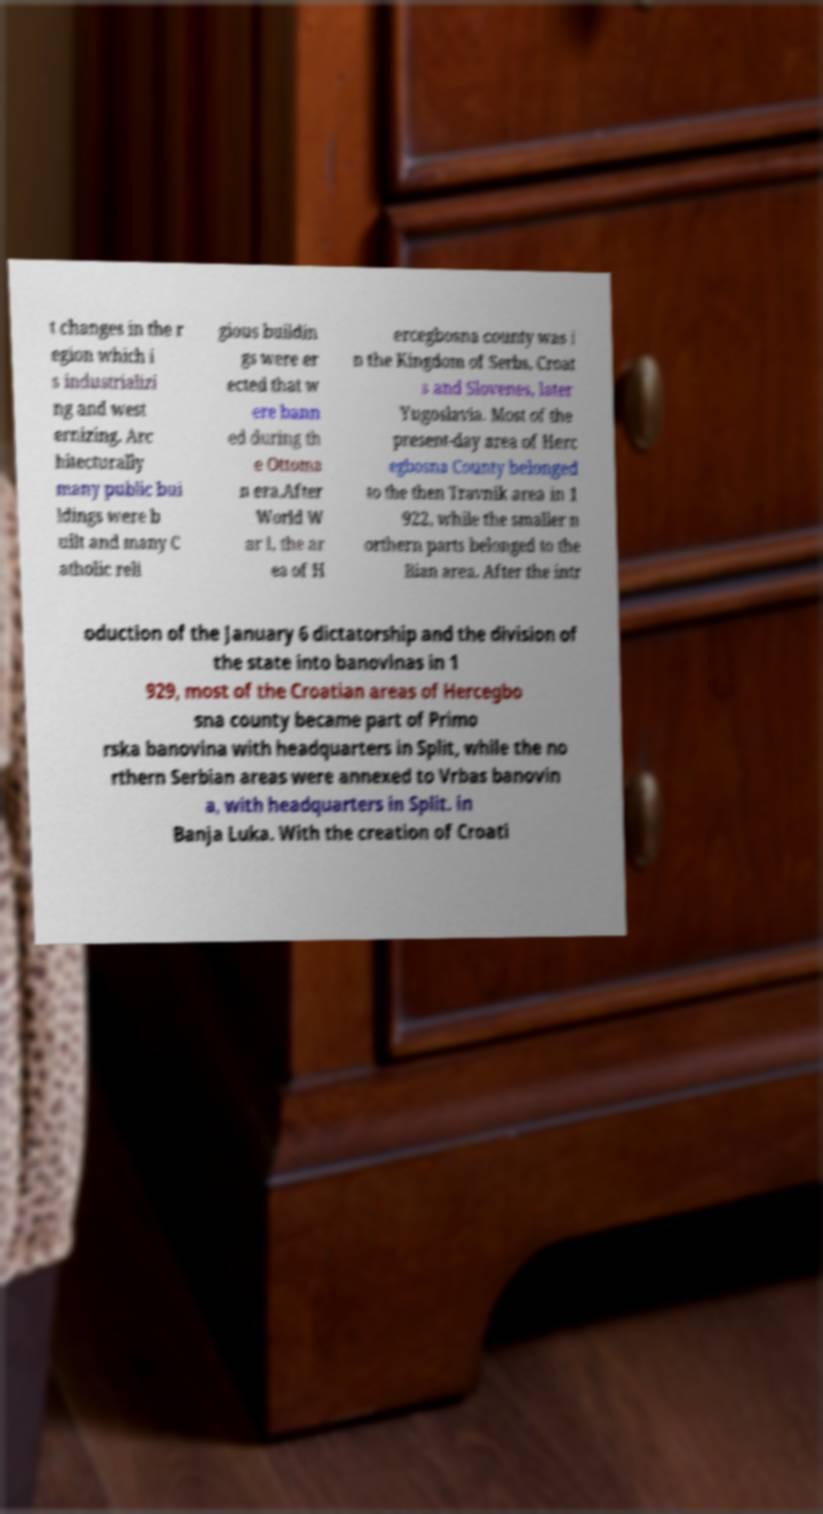There's text embedded in this image that I need extracted. Can you transcribe it verbatim? t changes in the r egion which i s industrializi ng and west ernizing. Arc hitecturally many public bui ldings were b uilt and many C atholic reli gious buildin gs were er ected that w ere bann ed during th e Ottoma n era.After World W ar I, the ar ea of H ercegbosna county was i n the Kingdom of Serbs, Croat s and Slovenes, later Yugoslavia. Most of the present-day area of Herc egbosna County belonged to the then Travnik area in 1 922, while the smaller n orthern parts belonged to the Bian area. After the intr oduction of the January 6 dictatorship and the division of the state into banovinas in 1 929, most of the Croatian areas of Hercegbo sna county became part of Primo rska banovina with headquarters in Split, while the no rthern Serbian areas were annexed to Vrbas banovin a, with headquarters in Split. in Banja Luka. With the creation of Croati 